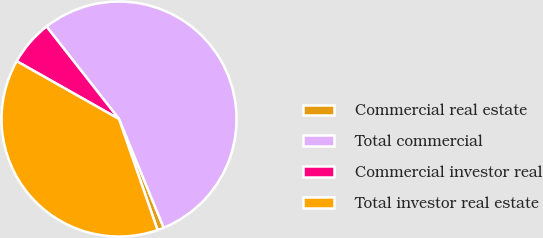Convert chart. <chart><loc_0><loc_0><loc_500><loc_500><pie_chart><fcel>Commercial real estate<fcel>Total commercial<fcel>Commercial investor real<fcel>Total investor real estate<nl><fcel>0.89%<fcel>54.37%<fcel>6.23%<fcel>38.51%<nl></chart> 